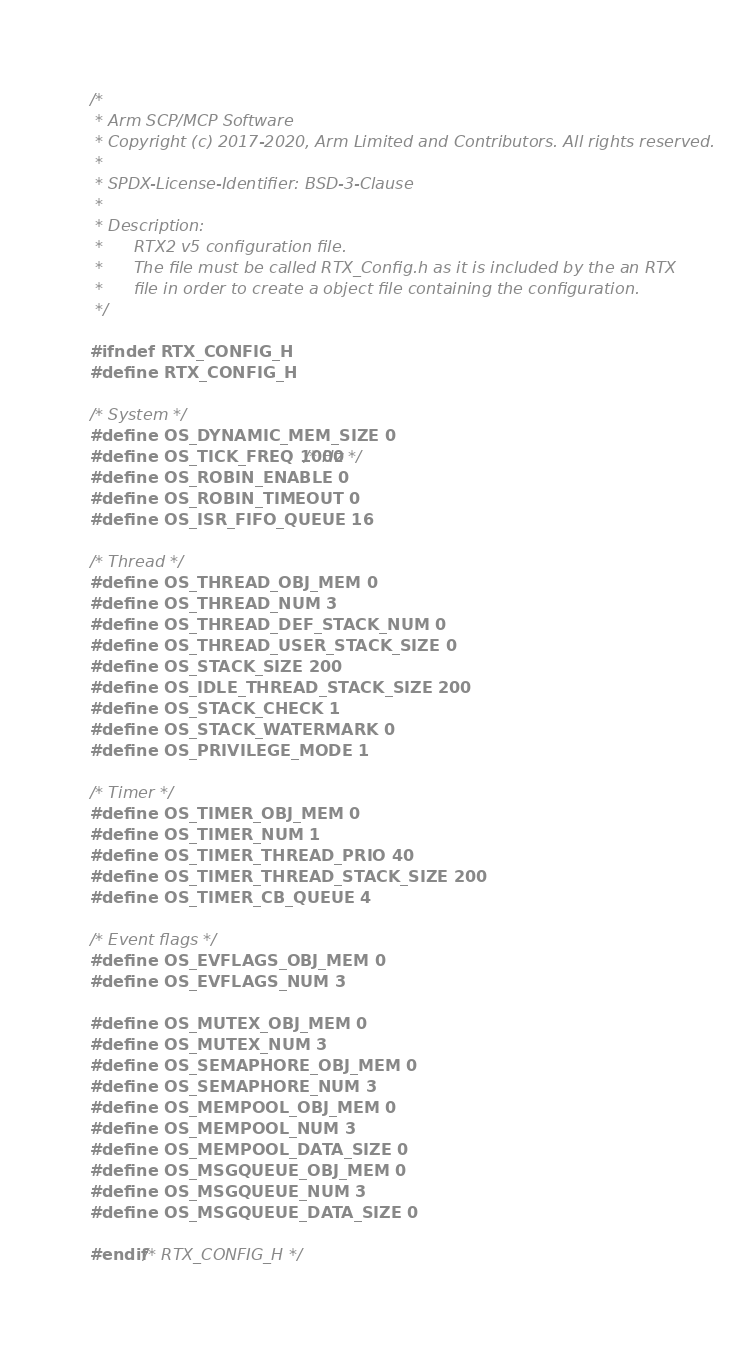<code> <loc_0><loc_0><loc_500><loc_500><_C_>/*
 * Arm SCP/MCP Software
 * Copyright (c) 2017-2020, Arm Limited and Contributors. All rights reserved.
 *
 * SPDX-License-Identifier: BSD-3-Clause
 *
 * Description:
 *      RTX2 v5 configuration file.
 *      The file must be called RTX_Config.h as it is included by the an RTX
 *      file in order to create a object file containing the configuration.
 */

#ifndef RTX_CONFIG_H
#define RTX_CONFIG_H

/* System */
#define OS_DYNAMIC_MEM_SIZE 0
#define OS_TICK_FREQ 1000 /* Hz */
#define OS_ROBIN_ENABLE 0
#define OS_ROBIN_TIMEOUT 0
#define OS_ISR_FIFO_QUEUE 16

/* Thread */
#define OS_THREAD_OBJ_MEM 0
#define OS_THREAD_NUM 3
#define OS_THREAD_DEF_STACK_NUM 0
#define OS_THREAD_USER_STACK_SIZE 0
#define OS_STACK_SIZE 200
#define OS_IDLE_THREAD_STACK_SIZE 200
#define OS_STACK_CHECK 1
#define OS_STACK_WATERMARK 0
#define OS_PRIVILEGE_MODE 1

/* Timer */
#define OS_TIMER_OBJ_MEM 0
#define OS_TIMER_NUM 1
#define OS_TIMER_THREAD_PRIO 40
#define OS_TIMER_THREAD_STACK_SIZE 200
#define OS_TIMER_CB_QUEUE 4

/* Event flags */
#define OS_EVFLAGS_OBJ_MEM 0
#define OS_EVFLAGS_NUM 3

#define OS_MUTEX_OBJ_MEM 0
#define OS_MUTEX_NUM 3
#define OS_SEMAPHORE_OBJ_MEM 0
#define OS_SEMAPHORE_NUM 3
#define OS_MEMPOOL_OBJ_MEM 0
#define OS_MEMPOOL_NUM 3
#define OS_MEMPOOL_DATA_SIZE 0
#define OS_MSGQUEUE_OBJ_MEM 0
#define OS_MSGQUEUE_NUM 3
#define OS_MSGQUEUE_DATA_SIZE 0

#endif /* RTX_CONFIG_H */
</code> 